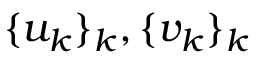Convert formula to latex. <formula><loc_0><loc_0><loc_500><loc_500>\{ u _ { k } \} _ { k } , \{ v _ { k } \} _ { k }</formula> 